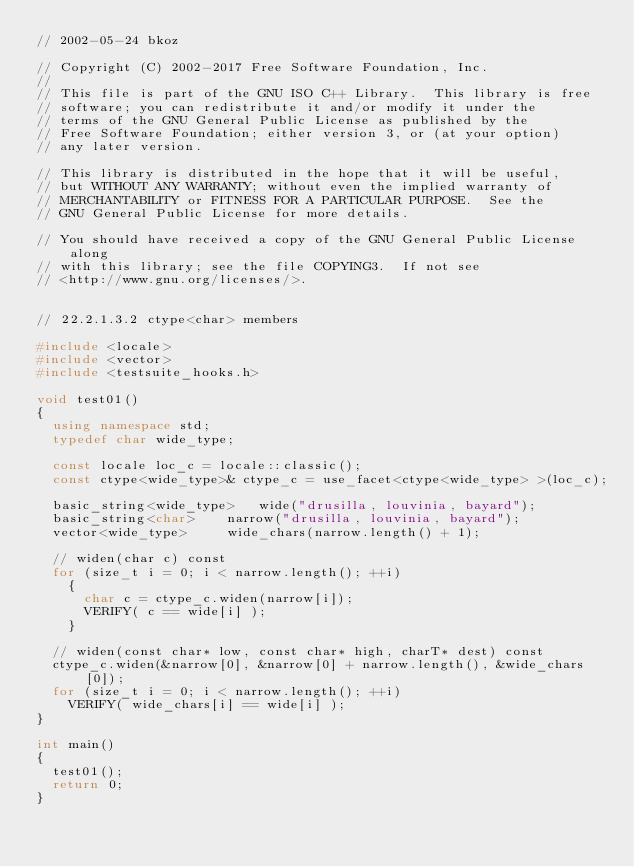Convert code to text. <code><loc_0><loc_0><loc_500><loc_500><_C++_>// 2002-05-24 bkoz

// Copyright (C) 2002-2017 Free Software Foundation, Inc.
//
// This file is part of the GNU ISO C++ Library.  This library is free
// software; you can redistribute it and/or modify it under the
// terms of the GNU General Public License as published by the
// Free Software Foundation; either version 3, or (at your option)
// any later version.

// This library is distributed in the hope that it will be useful,
// but WITHOUT ANY WARRANTY; without even the implied warranty of
// MERCHANTABILITY or FITNESS FOR A PARTICULAR PURPOSE.  See the
// GNU General Public License for more details.

// You should have received a copy of the GNU General Public License along
// with this library; see the file COPYING3.  If not see
// <http://www.gnu.org/licenses/>.


// 22.2.1.3.2 ctype<char> members

#include <locale>
#include <vector>
#include <testsuite_hooks.h>

void test01()
{
  using namespace std;
  typedef char wide_type;

  const locale loc_c = locale::classic();
  const ctype<wide_type>& ctype_c = use_facet<ctype<wide_type> >(loc_c); 

  basic_string<wide_type> 	wide("drusilla, louvinia, bayard");
  basic_string<char> 		narrow("drusilla, louvinia, bayard");
  vector<wide_type> 		wide_chars(narrow.length() + 1);
  
  // widen(char c) const
  for (size_t i = 0; i < narrow.length(); ++i)
    {
      char c = ctype_c.widen(narrow[i]);
      VERIFY( c == wide[i] );
    }

  // widen(const char* low, const char* high, charT* dest) const
  ctype_c.widen(&narrow[0], &narrow[0] + narrow.length(), &wide_chars[0]);  
  for (size_t i = 0; i < narrow.length(); ++i)
    VERIFY( wide_chars[i] == wide[i] );
}

int main() 
{
  test01();
  return 0;
}
</code> 